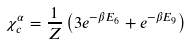Convert formula to latex. <formula><loc_0><loc_0><loc_500><loc_500>\chi ^ { \alpha } _ { c } = \frac { 1 } { Z } \left ( 3 e ^ { - \beta E _ { 6 } } + e ^ { - \beta E _ { 9 } } \right )</formula> 